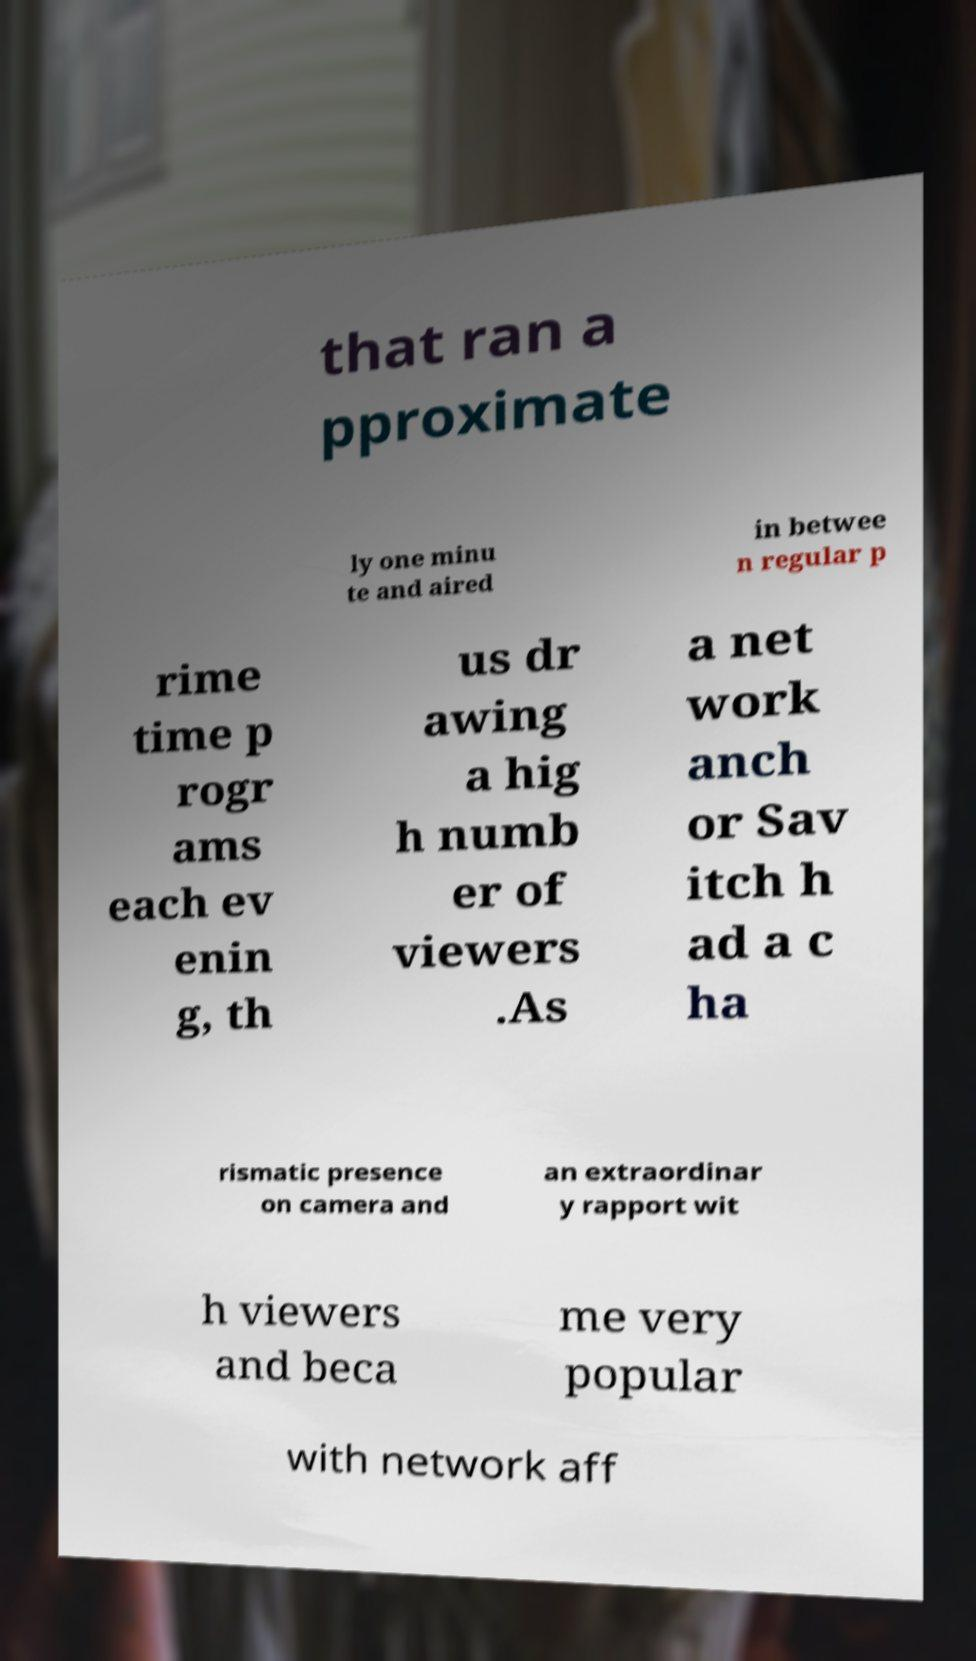There's text embedded in this image that I need extracted. Can you transcribe it verbatim? that ran a pproximate ly one minu te and aired in betwee n regular p rime time p rogr ams each ev enin g, th us dr awing a hig h numb er of viewers .As a net work anch or Sav itch h ad a c ha rismatic presence on camera and an extraordinar y rapport wit h viewers and beca me very popular with network aff 